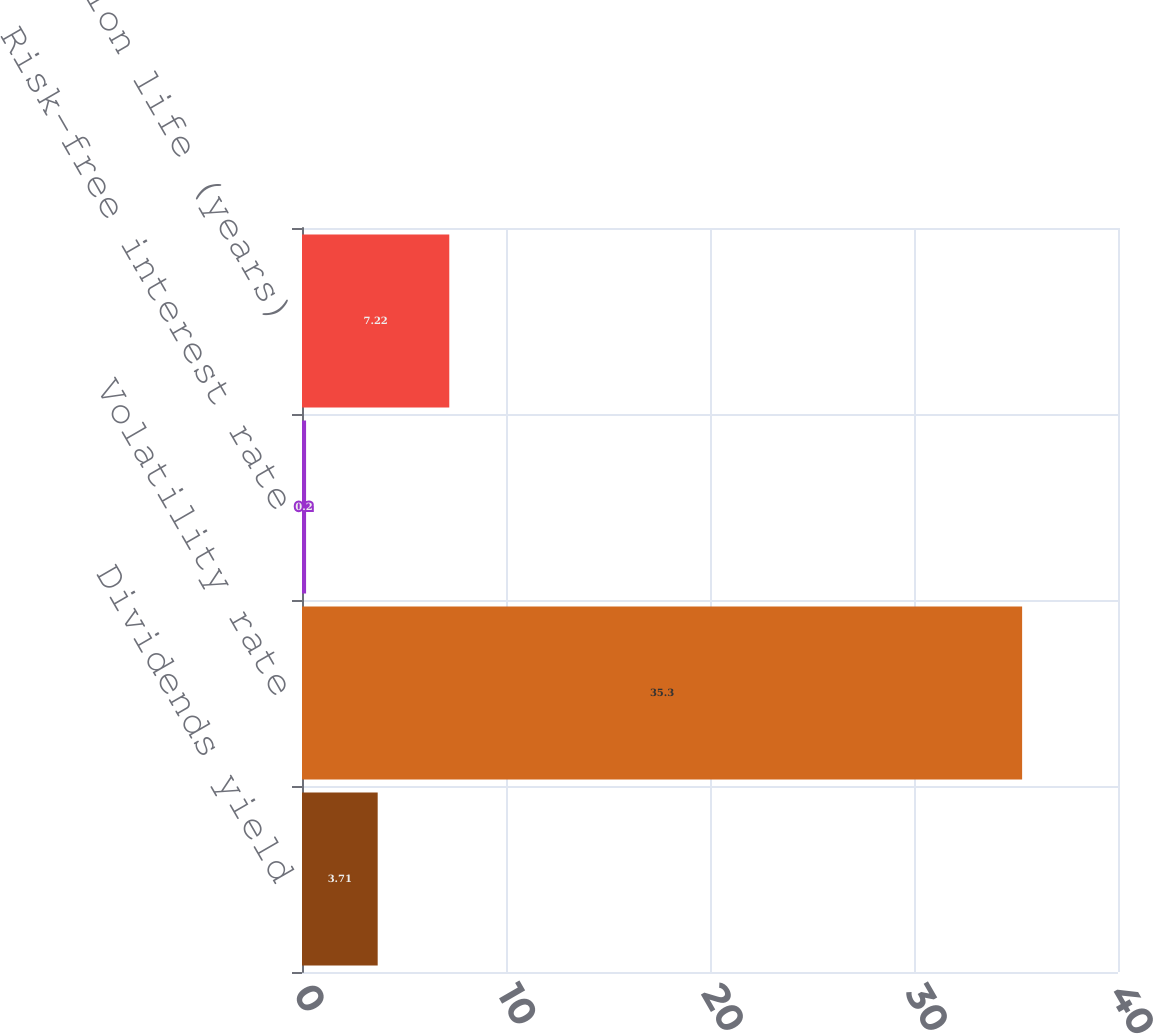Convert chart to OTSL. <chart><loc_0><loc_0><loc_500><loc_500><bar_chart><fcel>Dividends yield<fcel>Volatility rate<fcel>Risk-free interest rate<fcel>Expected option life (years)<nl><fcel>3.71<fcel>35.3<fcel>0.2<fcel>7.22<nl></chart> 